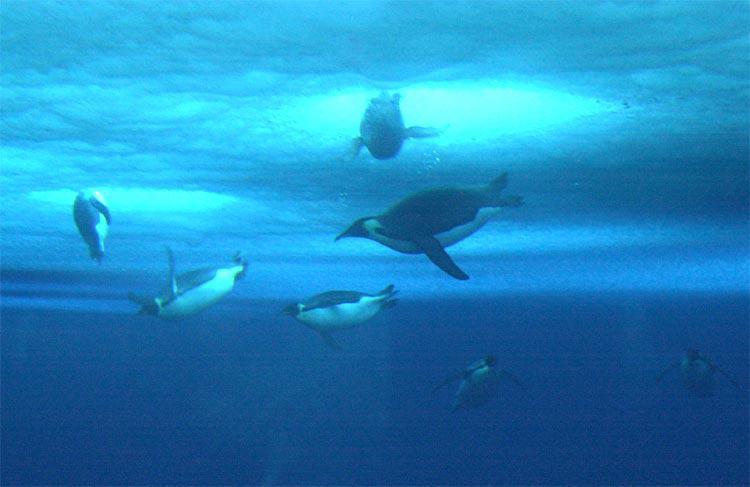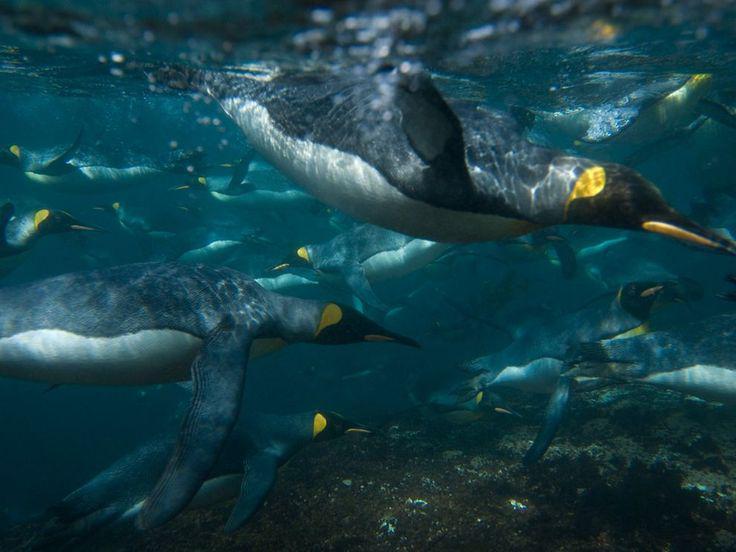The first image is the image on the left, the second image is the image on the right. Analyze the images presented: Is the assertion "There are more than 10 penguins swimming." valid? Answer yes or no. Yes. 